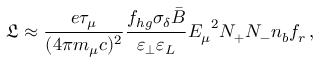Convert formula to latex. <formula><loc_0><loc_0><loc_500><loc_500>\mathfrak { L } \approx \frac { e \tau _ { \mu } } { ( 4 \pi m _ { \mu } c ) ^ { 2 } } \frac { f _ { h g } \sigma _ { \delta } \bar { B } } { \varepsilon _ { \perp } \varepsilon _ { L } } { E _ { \mu } } ^ { 2 } N _ { + } N _ { - } n _ { b } f _ { r } \, ,</formula> 